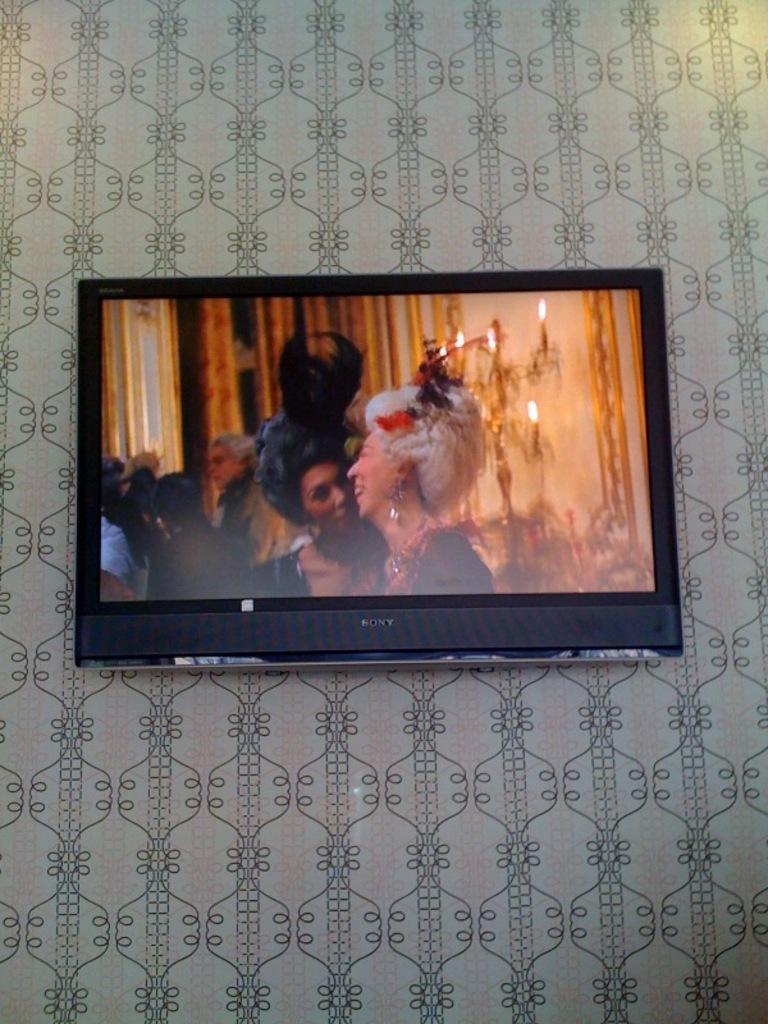In one or two sentences, can you explain what this image depicts? In this image we can see a television attached to the wall and in the television, we can see the picture of some people. 